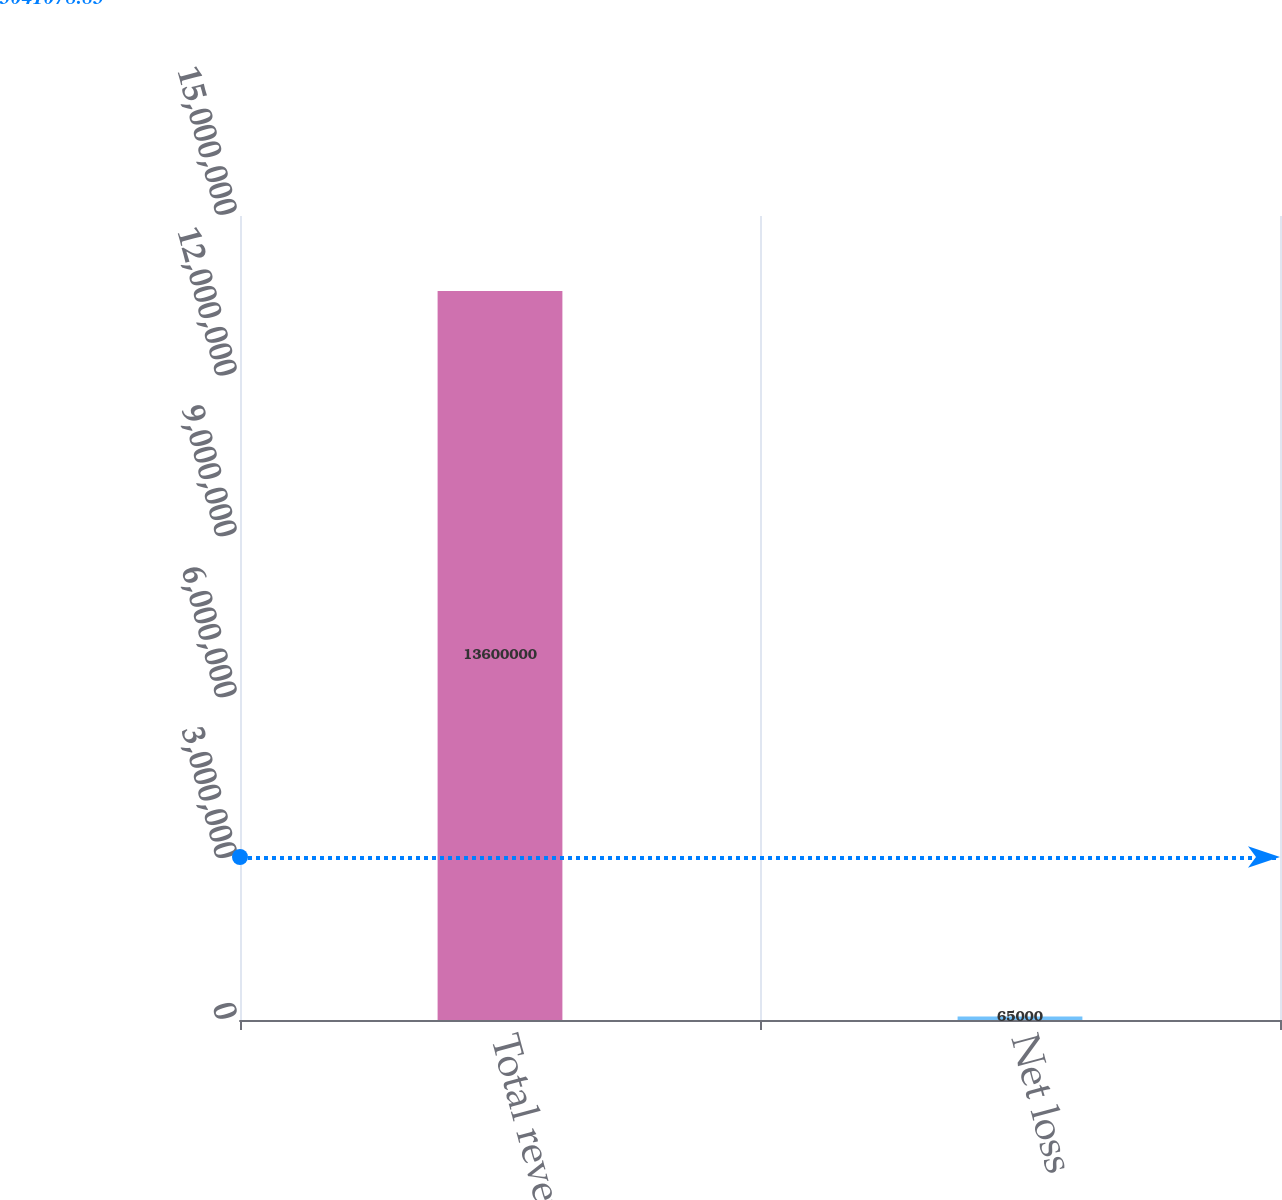<chart> <loc_0><loc_0><loc_500><loc_500><bar_chart><fcel>Total revenue<fcel>Net loss<nl><fcel>1.36e+07<fcel>65000<nl></chart> 